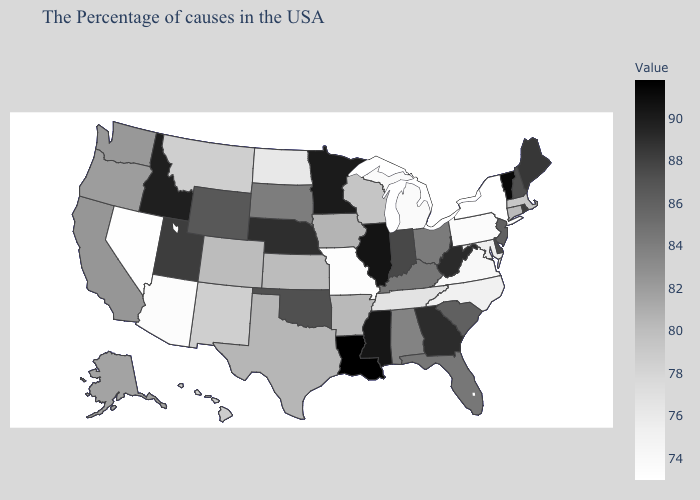Among the states that border Minnesota , does Wisconsin have the highest value?
Quick response, please. No. Does the map have missing data?
Write a very short answer. No. Does Hawaii have the lowest value in the West?
Concise answer only. No. Among the states that border Louisiana , does Mississippi have the lowest value?
Concise answer only. No. Does Louisiana have the highest value in the USA?
Write a very short answer. Yes. Among the states that border Maine , which have the lowest value?
Short answer required. New Hampshire. 